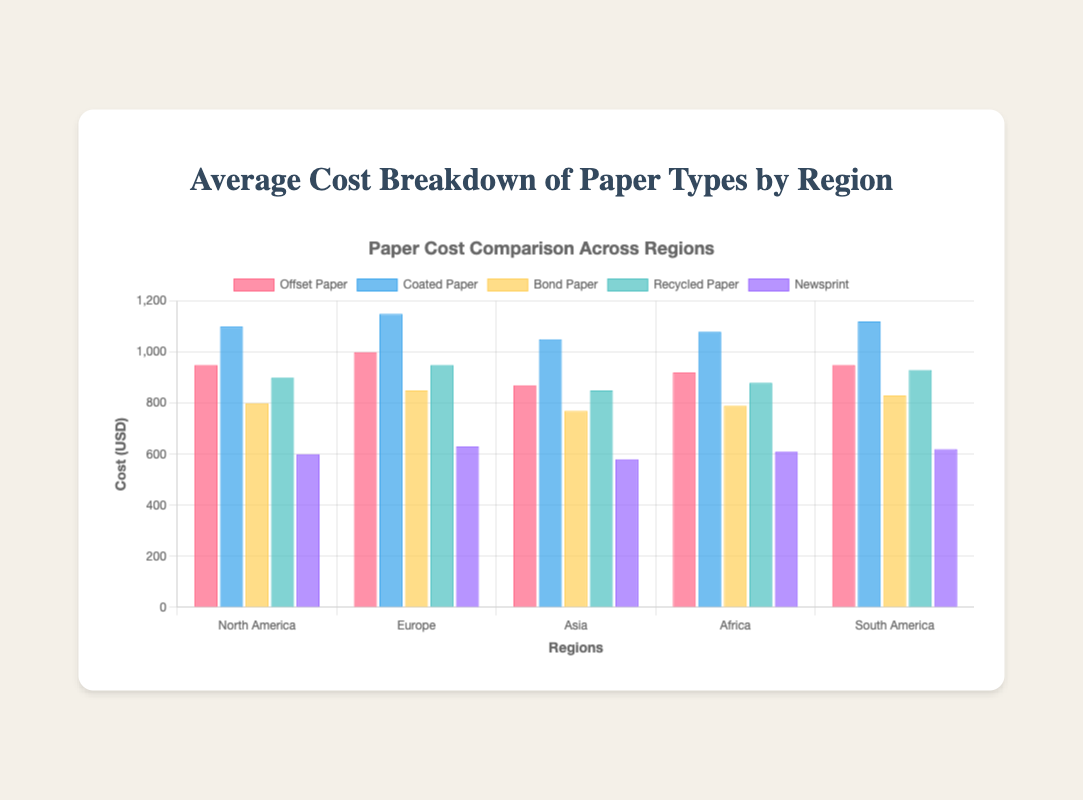What is the average cost of Offset Paper across all regions? To calculate this, we sum the costs of Offset Paper in all regions: 950 (North America) + 1000 (Europe) + 870 (Asia) + 920 (Africa) + 950 (South America) = 4690. Then we divide by the number of regions, which is 5. The average cost is 4690 / 5 = 938
Answer: 938 Which region has the highest cost for Coated Paper? We compare the costs for Coated Paper across all regions: North America (1100), Europe (1150), Asia (1050), Africa (1080), and South America (1120). Europe has the highest cost at 1150
Answer: Europe How much more expensive is Bond Paper in Europe compared to Asia? The cost of Bond Paper in Europe is 850, while in Asia it is 770. The difference is 850 - 770 = 80
Answer: 80 Which paper type is the least expensive in North America? We compare the costs of all paper types in North America: Offset Paper (950), Coated Paper (1100), Bond Paper (800), Recycled Paper (900), and Newsprint (600). Newsprint is the least expensive at 600
Answer: Newsprint What's the total cost of Coated Paper across all regions? Sum the costs of Coated Paper in all regions: 1100 (North America) + 1150 (Europe) + 1050 (Asia) + 1080 (Africa) + 1120 (South America) = 5500
Answer: 5500 Which paper type shows the most uniform price distribution across all regions? To determine uniformity, look at the cost variation of each paper type across regions. Offset Paper (950, 1000, 870, 920, 950), Coated Paper (1100, 1150, 1050, 1080, 1120), Bond Paper (800, 850, 770, 790, 830), Recycled Paper (900, 950, 850, 880, 930), Newsprint (600, 630, 580, 610, 620). Offset Paper and Recycled Paper show relatively uniform distribution, with lower variability in prices. Offset Paper edges out slightly with more consistent figures.
Answer: Offset Paper What is the difference between the highest and lowest cost of Recycled Paper across all regions? The highest cost of Recycled Paper is in Europe (950) and the lowest is in Asia (850). The difference is 950 - 850 = 100
Answer: 100 How does the cost of Newsprint in Africa compare to that in South America? The cost of Newsprint in Africa is 610, while in South America it is 620. Africa’s cost is slightly lower by 10
Answer: Africa Which region has the most diverse cost portfolio across the different paper types? To find the most diverse cost portfolio, we look at the range of costs (max - min) for each region: North America (1100 - 600 = 500), Europe (1150 - 630 = 520), Asia (1050 - 580 = 470), Africa (1080 - 610 = 470), and South America (1120 - 620 = 500). Europe has the highest range, indicating the most diverse cost portfolio.
Answer: Europe 